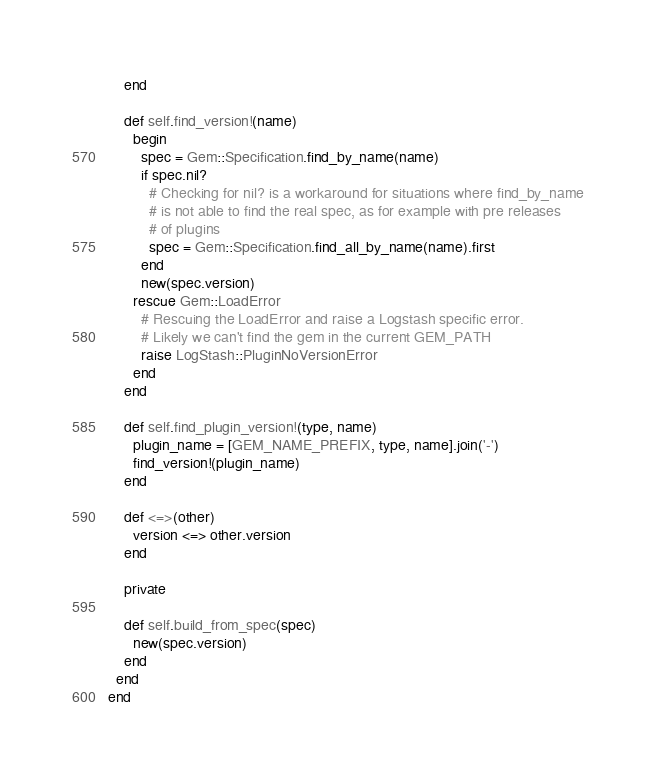Convert code to text. <code><loc_0><loc_0><loc_500><loc_500><_Ruby_>    end

    def self.find_version!(name)
      begin
        spec = Gem::Specification.find_by_name(name)
        if spec.nil?
          # Checking for nil? is a workaround for situations where find_by_name
          # is not able to find the real spec, as for example with pre releases
          # of plugins
          spec = Gem::Specification.find_all_by_name(name).first
        end
        new(spec.version)
      rescue Gem::LoadError
        # Rescuing the LoadError and raise a Logstash specific error.
        # Likely we can't find the gem in the current GEM_PATH
        raise LogStash::PluginNoVersionError
      end
    end

    def self.find_plugin_version!(type, name)
      plugin_name = [GEM_NAME_PREFIX, type, name].join('-')
      find_version!(plugin_name)
    end

    def <=>(other)
      version <=> other.version
    end

    private

    def self.build_from_spec(spec)
      new(spec.version)
    end
  end
end
</code> 